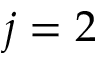<formula> <loc_0><loc_0><loc_500><loc_500>j = 2</formula> 